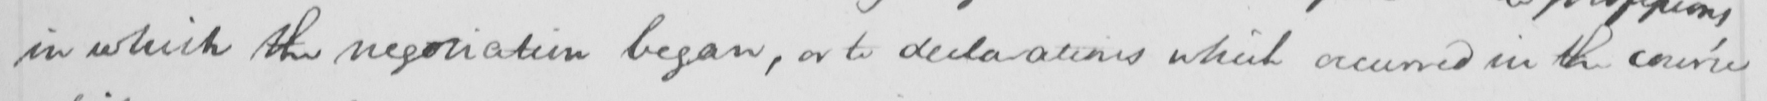What does this handwritten line say? in which the negotiation began , or to declarations which occurred in the course 